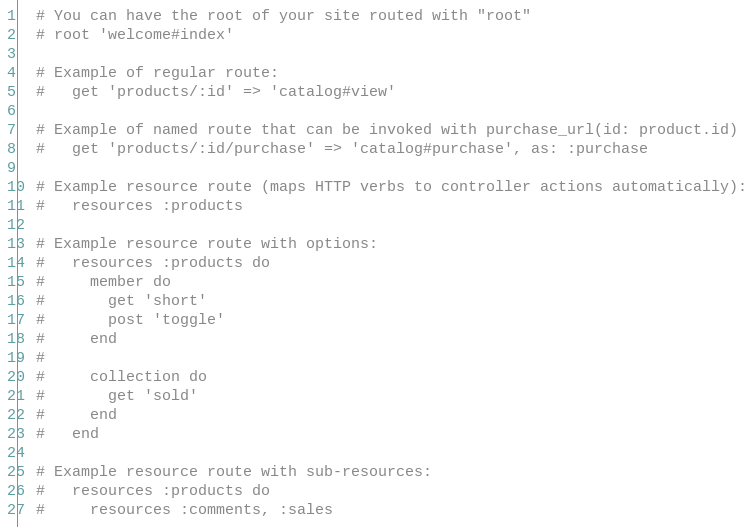<code> <loc_0><loc_0><loc_500><loc_500><_Ruby_>  # You can have the root of your site routed with "root"
  # root 'welcome#index'

  # Example of regular route:
  #   get 'products/:id' => 'catalog#view'

  # Example of named route that can be invoked with purchase_url(id: product.id)
  #   get 'products/:id/purchase' => 'catalog#purchase', as: :purchase

  # Example resource route (maps HTTP verbs to controller actions automatically):
  #   resources :products

  # Example resource route with options:
  #   resources :products do
  #     member do
  #       get 'short'
  #       post 'toggle'
  #     end
  #
  #     collection do
  #       get 'sold'
  #     end
  #   end

  # Example resource route with sub-resources:
  #   resources :products do
  #     resources :comments, :sales</code> 